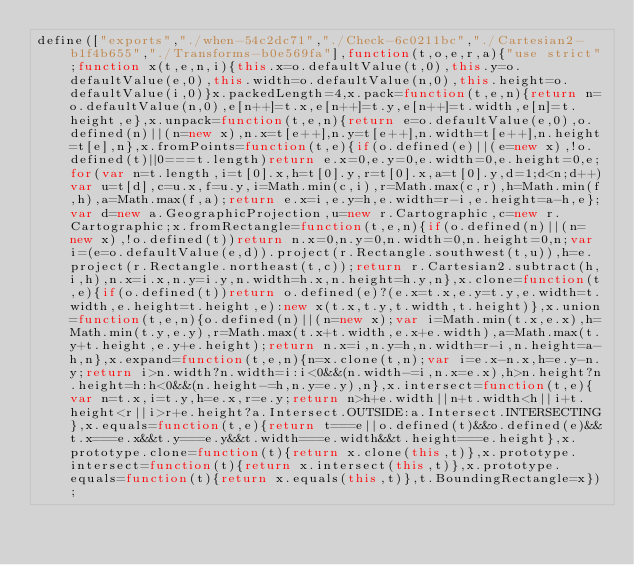Convert code to text. <code><loc_0><loc_0><loc_500><loc_500><_JavaScript_>define(["exports","./when-54c2dc71","./Check-6c0211bc","./Cartesian2-b1f4b655","./Transforms-b0e569fa"],function(t,o,e,r,a){"use strict";function x(t,e,n,i){this.x=o.defaultValue(t,0),this.y=o.defaultValue(e,0),this.width=o.defaultValue(n,0),this.height=o.defaultValue(i,0)}x.packedLength=4,x.pack=function(t,e,n){return n=o.defaultValue(n,0),e[n++]=t.x,e[n++]=t.y,e[n++]=t.width,e[n]=t.height,e},x.unpack=function(t,e,n){return e=o.defaultValue(e,0),o.defined(n)||(n=new x),n.x=t[e++],n.y=t[e++],n.width=t[e++],n.height=t[e],n},x.fromPoints=function(t,e){if(o.defined(e)||(e=new x),!o.defined(t)||0===t.length)return e.x=0,e.y=0,e.width=0,e.height=0,e;for(var n=t.length,i=t[0].x,h=t[0].y,r=t[0].x,a=t[0].y,d=1;d<n;d++)var u=t[d],c=u.x,f=u.y,i=Math.min(c,i),r=Math.max(c,r),h=Math.min(f,h),a=Math.max(f,a);return e.x=i,e.y=h,e.width=r-i,e.height=a-h,e};var d=new a.GeographicProjection,u=new r.Cartographic,c=new r.Cartographic;x.fromRectangle=function(t,e,n){if(o.defined(n)||(n=new x),!o.defined(t))return n.x=0,n.y=0,n.width=0,n.height=0,n;var i=(e=o.defaultValue(e,d)).project(r.Rectangle.southwest(t,u)),h=e.project(r.Rectangle.northeast(t,c));return r.Cartesian2.subtract(h,i,h),n.x=i.x,n.y=i.y,n.width=h.x,n.height=h.y,n},x.clone=function(t,e){if(o.defined(t))return o.defined(e)?(e.x=t.x,e.y=t.y,e.width=t.width,e.height=t.height,e):new x(t.x,t.y,t.width,t.height)},x.union=function(t,e,n){o.defined(n)||(n=new x);var i=Math.min(t.x,e.x),h=Math.min(t.y,e.y),r=Math.max(t.x+t.width,e.x+e.width),a=Math.max(t.y+t.height,e.y+e.height);return n.x=i,n.y=h,n.width=r-i,n.height=a-h,n},x.expand=function(t,e,n){n=x.clone(t,n);var i=e.x-n.x,h=e.y-n.y;return i>n.width?n.width=i:i<0&&(n.width-=i,n.x=e.x),h>n.height?n.height=h:h<0&&(n.height-=h,n.y=e.y),n},x.intersect=function(t,e){var n=t.x,i=t.y,h=e.x,r=e.y;return n>h+e.width||n+t.width<h||i+t.height<r||i>r+e.height?a.Intersect.OUTSIDE:a.Intersect.INTERSECTING},x.equals=function(t,e){return t===e||o.defined(t)&&o.defined(e)&&t.x===e.x&&t.y===e.y&&t.width===e.width&&t.height===e.height},x.prototype.clone=function(t){return x.clone(this,t)},x.prototype.intersect=function(t){return x.intersect(this,t)},x.prototype.equals=function(t){return x.equals(this,t)},t.BoundingRectangle=x});
</code> 